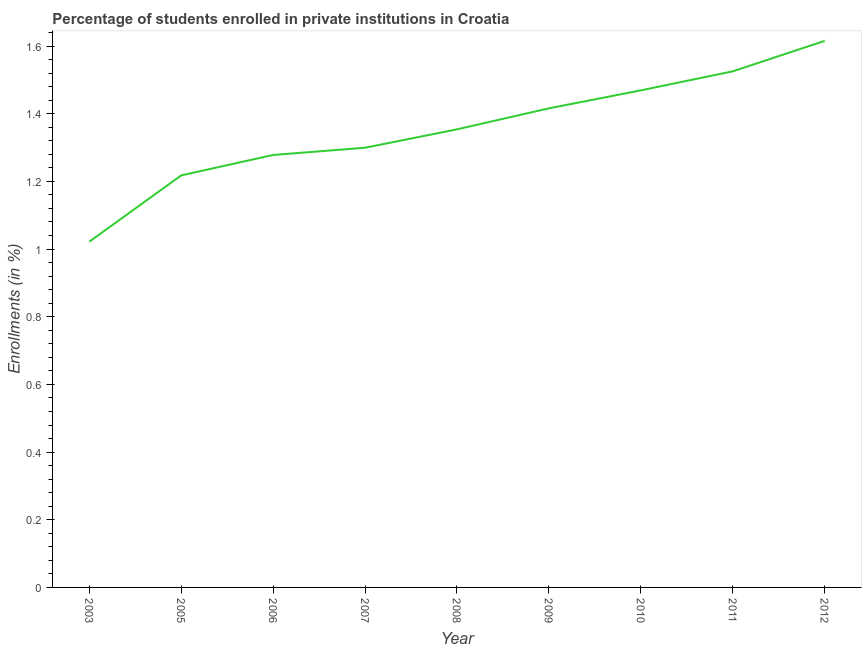What is the enrollments in private institutions in 2006?
Give a very brief answer. 1.28. Across all years, what is the maximum enrollments in private institutions?
Ensure brevity in your answer.  1.62. Across all years, what is the minimum enrollments in private institutions?
Give a very brief answer. 1.02. In which year was the enrollments in private institutions maximum?
Your answer should be compact. 2012. What is the sum of the enrollments in private institutions?
Your answer should be compact. 12.2. What is the difference between the enrollments in private institutions in 2005 and 2007?
Provide a succinct answer. -0.08. What is the average enrollments in private institutions per year?
Offer a terse response. 1.36. What is the median enrollments in private institutions?
Give a very brief answer. 1.35. In how many years, is the enrollments in private institutions greater than 1.04 %?
Provide a succinct answer. 8. What is the ratio of the enrollments in private institutions in 2010 to that in 2012?
Ensure brevity in your answer.  0.91. Is the enrollments in private institutions in 2006 less than that in 2010?
Give a very brief answer. Yes. Is the difference between the enrollments in private institutions in 2005 and 2006 greater than the difference between any two years?
Provide a succinct answer. No. What is the difference between the highest and the second highest enrollments in private institutions?
Provide a short and direct response. 0.09. Is the sum of the enrollments in private institutions in 2008 and 2010 greater than the maximum enrollments in private institutions across all years?
Your answer should be compact. Yes. What is the difference between the highest and the lowest enrollments in private institutions?
Offer a very short reply. 0.59. In how many years, is the enrollments in private institutions greater than the average enrollments in private institutions taken over all years?
Give a very brief answer. 4. How many years are there in the graph?
Keep it short and to the point. 9. Are the values on the major ticks of Y-axis written in scientific E-notation?
Give a very brief answer. No. Does the graph contain grids?
Your answer should be compact. No. What is the title of the graph?
Your response must be concise. Percentage of students enrolled in private institutions in Croatia. What is the label or title of the X-axis?
Offer a terse response. Year. What is the label or title of the Y-axis?
Keep it short and to the point. Enrollments (in %). What is the Enrollments (in %) in 2003?
Provide a succinct answer. 1.02. What is the Enrollments (in %) in 2005?
Offer a very short reply. 1.22. What is the Enrollments (in %) of 2006?
Your answer should be very brief. 1.28. What is the Enrollments (in %) of 2007?
Offer a terse response. 1.3. What is the Enrollments (in %) in 2008?
Your answer should be very brief. 1.35. What is the Enrollments (in %) in 2009?
Provide a short and direct response. 1.42. What is the Enrollments (in %) in 2010?
Make the answer very short. 1.47. What is the Enrollments (in %) of 2011?
Provide a succinct answer. 1.53. What is the Enrollments (in %) in 2012?
Provide a short and direct response. 1.62. What is the difference between the Enrollments (in %) in 2003 and 2005?
Keep it short and to the point. -0.2. What is the difference between the Enrollments (in %) in 2003 and 2006?
Offer a terse response. -0.26. What is the difference between the Enrollments (in %) in 2003 and 2007?
Ensure brevity in your answer.  -0.28. What is the difference between the Enrollments (in %) in 2003 and 2008?
Ensure brevity in your answer.  -0.33. What is the difference between the Enrollments (in %) in 2003 and 2009?
Ensure brevity in your answer.  -0.39. What is the difference between the Enrollments (in %) in 2003 and 2010?
Provide a succinct answer. -0.45. What is the difference between the Enrollments (in %) in 2003 and 2011?
Give a very brief answer. -0.5. What is the difference between the Enrollments (in %) in 2003 and 2012?
Offer a terse response. -0.59. What is the difference between the Enrollments (in %) in 2005 and 2006?
Make the answer very short. -0.06. What is the difference between the Enrollments (in %) in 2005 and 2007?
Ensure brevity in your answer.  -0.08. What is the difference between the Enrollments (in %) in 2005 and 2008?
Your response must be concise. -0.14. What is the difference between the Enrollments (in %) in 2005 and 2009?
Make the answer very short. -0.2. What is the difference between the Enrollments (in %) in 2005 and 2010?
Your answer should be compact. -0.25. What is the difference between the Enrollments (in %) in 2005 and 2011?
Offer a terse response. -0.31. What is the difference between the Enrollments (in %) in 2005 and 2012?
Keep it short and to the point. -0.4. What is the difference between the Enrollments (in %) in 2006 and 2007?
Offer a terse response. -0.02. What is the difference between the Enrollments (in %) in 2006 and 2008?
Your answer should be very brief. -0.08. What is the difference between the Enrollments (in %) in 2006 and 2009?
Make the answer very short. -0.14. What is the difference between the Enrollments (in %) in 2006 and 2010?
Offer a very short reply. -0.19. What is the difference between the Enrollments (in %) in 2006 and 2011?
Make the answer very short. -0.25. What is the difference between the Enrollments (in %) in 2006 and 2012?
Keep it short and to the point. -0.34. What is the difference between the Enrollments (in %) in 2007 and 2008?
Provide a short and direct response. -0.05. What is the difference between the Enrollments (in %) in 2007 and 2009?
Ensure brevity in your answer.  -0.12. What is the difference between the Enrollments (in %) in 2007 and 2010?
Ensure brevity in your answer.  -0.17. What is the difference between the Enrollments (in %) in 2007 and 2011?
Your response must be concise. -0.23. What is the difference between the Enrollments (in %) in 2007 and 2012?
Your response must be concise. -0.32. What is the difference between the Enrollments (in %) in 2008 and 2009?
Give a very brief answer. -0.06. What is the difference between the Enrollments (in %) in 2008 and 2010?
Give a very brief answer. -0.12. What is the difference between the Enrollments (in %) in 2008 and 2011?
Ensure brevity in your answer.  -0.17. What is the difference between the Enrollments (in %) in 2008 and 2012?
Offer a terse response. -0.26. What is the difference between the Enrollments (in %) in 2009 and 2010?
Your answer should be compact. -0.05. What is the difference between the Enrollments (in %) in 2009 and 2011?
Provide a short and direct response. -0.11. What is the difference between the Enrollments (in %) in 2009 and 2012?
Make the answer very short. -0.2. What is the difference between the Enrollments (in %) in 2010 and 2011?
Your answer should be very brief. -0.06. What is the difference between the Enrollments (in %) in 2010 and 2012?
Offer a terse response. -0.15. What is the difference between the Enrollments (in %) in 2011 and 2012?
Offer a very short reply. -0.09. What is the ratio of the Enrollments (in %) in 2003 to that in 2005?
Your response must be concise. 0.84. What is the ratio of the Enrollments (in %) in 2003 to that in 2006?
Keep it short and to the point. 0.8. What is the ratio of the Enrollments (in %) in 2003 to that in 2007?
Offer a very short reply. 0.79. What is the ratio of the Enrollments (in %) in 2003 to that in 2008?
Your answer should be compact. 0.76. What is the ratio of the Enrollments (in %) in 2003 to that in 2009?
Your answer should be compact. 0.72. What is the ratio of the Enrollments (in %) in 2003 to that in 2010?
Keep it short and to the point. 0.7. What is the ratio of the Enrollments (in %) in 2003 to that in 2011?
Offer a very short reply. 0.67. What is the ratio of the Enrollments (in %) in 2003 to that in 2012?
Give a very brief answer. 0.63. What is the ratio of the Enrollments (in %) in 2005 to that in 2006?
Provide a succinct answer. 0.95. What is the ratio of the Enrollments (in %) in 2005 to that in 2007?
Keep it short and to the point. 0.94. What is the ratio of the Enrollments (in %) in 2005 to that in 2008?
Give a very brief answer. 0.9. What is the ratio of the Enrollments (in %) in 2005 to that in 2009?
Ensure brevity in your answer.  0.86. What is the ratio of the Enrollments (in %) in 2005 to that in 2010?
Offer a very short reply. 0.83. What is the ratio of the Enrollments (in %) in 2005 to that in 2011?
Ensure brevity in your answer.  0.8. What is the ratio of the Enrollments (in %) in 2005 to that in 2012?
Give a very brief answer. 0.75. What is the ratio of the Enrollments (in %) in 2006 to that in 2007?
Make the answer very short. 0.98. What is the ratio of the Enrollments (in %) in 2006 to that in 2008?
Make the answer very short. 0.94. What is the ratio of the Enrollments (in %) in 2006 to that in 2009?
Ensure brevity in your answer.  0.9. What is the ratio of the Enrollments (in %) in 2006 to that in 2010?
Give a very brief answer. 0.87. What is the ratio of the Enrollments (in %) in 2006 to that in 2011?
Provide a short and direct response. 0.84. What is the ratio of the Enrollments (in %) in 2006 to that in 2012?
Your answer should be very brief. 0.79. What is the ratio of the Enrollments (in %) in 2007 to that in 2009?
Keep it short and to the point. 0.92. What is the ratio of the Enrollments (in %) in 2007 to that in 2010?
Provide a succinct answer. 0.89. What is the ratio of the Enrollments (in %) in 2007 to that in 2011?
Your answer should be very brief. 0.85. What is the ratio of the Enrollments (in %) in 2007 to that in 2012?
Offer a very short reply. 0.8. What is the ratio of the Enrollments (in %) in 2008 to that in 2009?
Your response must be concise. 0.96. What is the ratio of the Enrollments (in %) in 2008 to that in 2010?
Offer a terse response. 0.92. What is the ratio of the Enrollments (in %) in 2008 to that in 2011?
Your response must be concise. 0.89. What is the ratio of the Enrollments (in %) in 2008 to that in 2012?
Offer a very short reply. 0.84. What is the ratio of the Enrollments (in %) in 2009 to that in 2011?
Make the answer very short. 0.93. What is the ratio of the Enrollments (in %) in 2009 to that in 2012?
Make the answer very short. 0.88. What is the ratio of the Enrollments (in %) in 2010 to that in 2011?
Your answer should be very brief. 0.96. What is the ratio of the Enrollments (in %) in 2010 to that in 2012?
Your answer should be compact. 0.91. What is the ratio of the Enrollments (in %) in 2011 to that in 2012?
Provide a succinct answer. 0.94. 